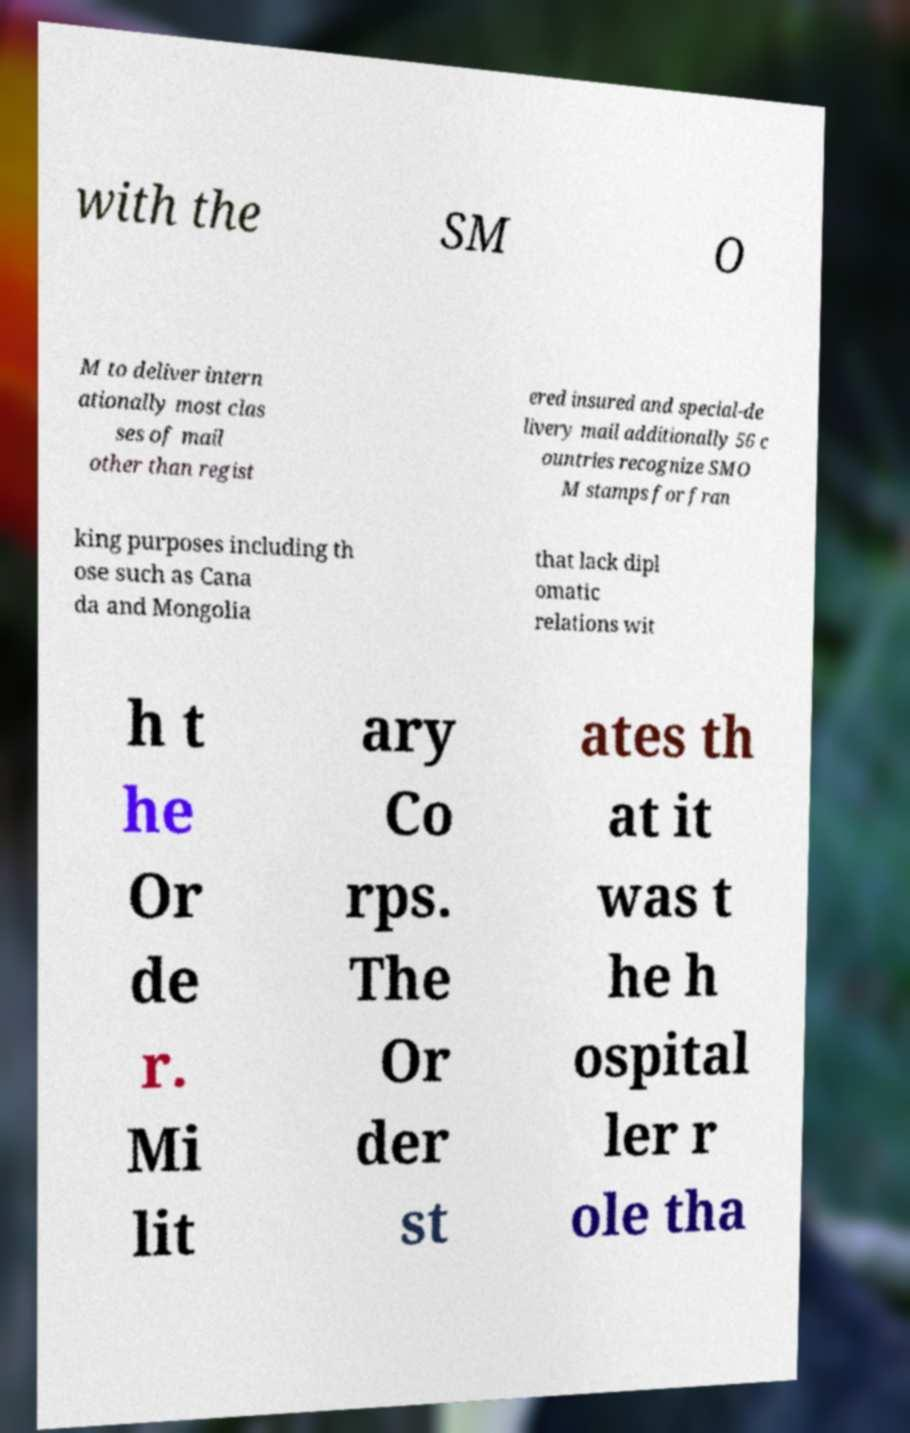For documentation purposes, I need the text within this image transcribed. Could you provide that? with the SM O M to deliver intern ationally most clas ses of mail other than regist ered insured and special-de livery mail additionally 56 c ountries recognize SMO M stamps for fran king purposes including th ose such as Cana da and Mongolia that lack dipl omatic relations wit h t he Or de r. Mi lit ary Co rps. The Or der st ates th at it was t he h ospital ler r ole tha 